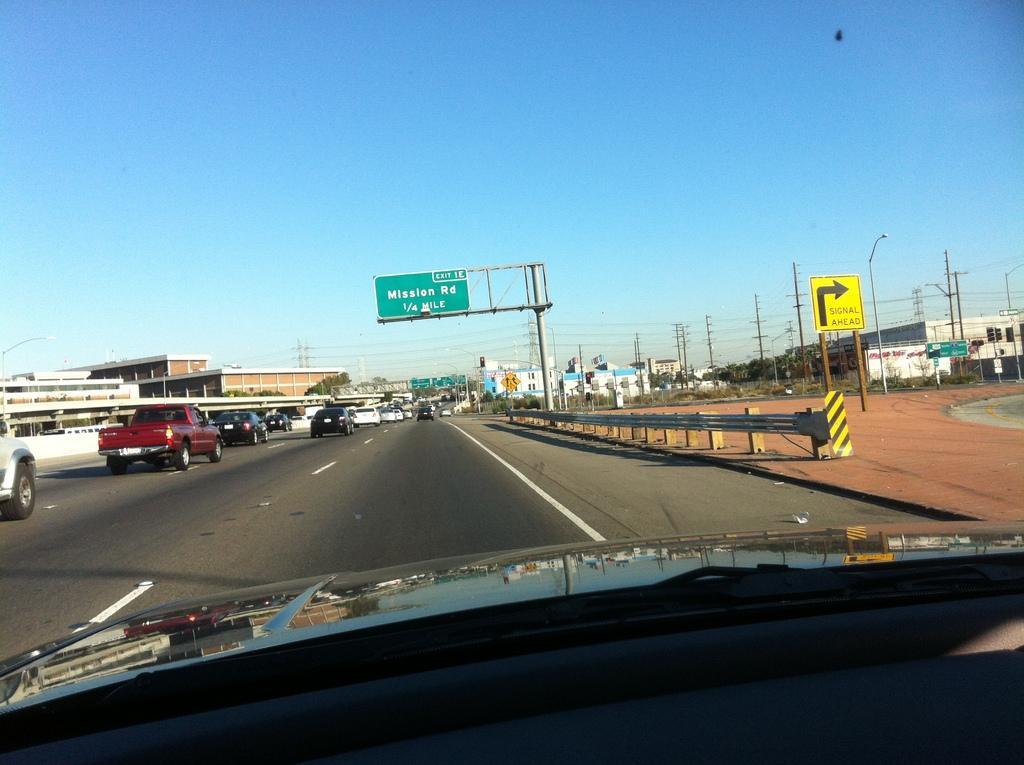Please provide a concise description of this image. In the image we can see there is an outside view from the car. There are vehicles parked on the road and there are buildings. 